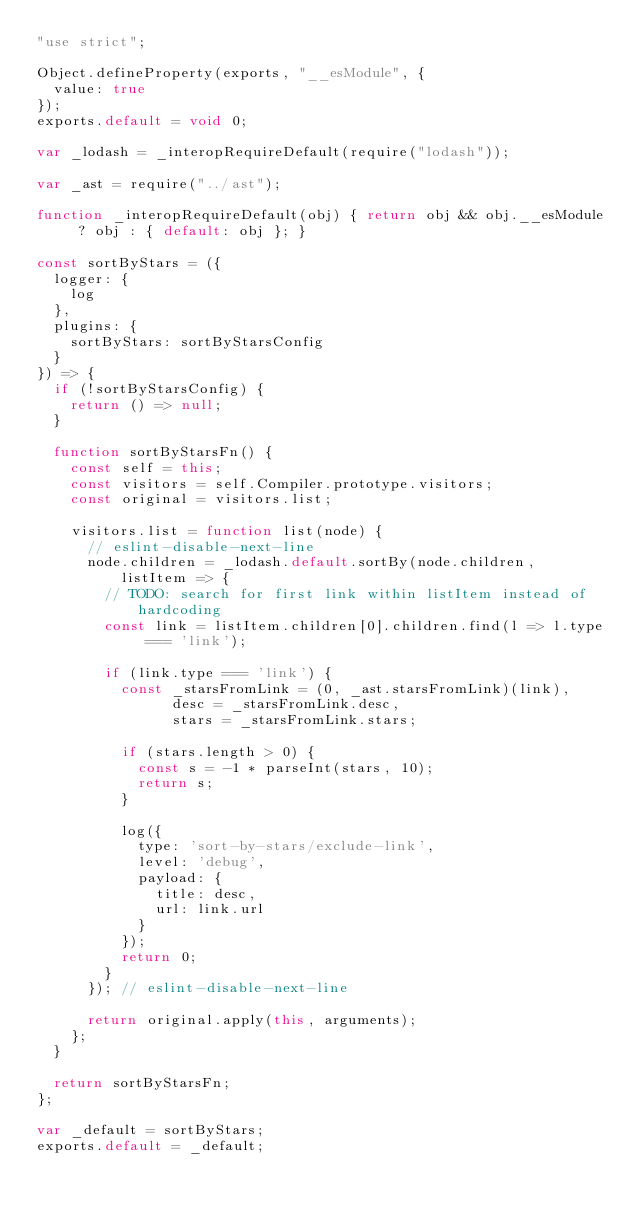Convert code to text. <code><loc_0><loc_0><loc_500><loc_500><_JavaScript_>"use strict";

Object.defineProperty(exports, "__esModule", {
  value: true
});
exports.default = void 0;

var _lodash = _interopRequireDefault(require("lodash"));

var _ast = require("../ast");

function _interopRequireDefault(obj) { return obj && obj.__esModule ? obj : { default: obj }; }

const sortByStars = ({
  logger: {
    log
  },
  plugins: {
    sortByStars: sortByStarsConfig
  }
}) => {
  if (!sortByStarsConfig) {
    return () => null;
  }

  function sortByStarsFn() {
    const self = this;
    const visitors = self.Compiler.prototype.visitors;
    const original = visitors.list;

    visitors.list = function list(node) {
      // eslint-disable-next-line
      node.children = _lodash.default.sortBy(node.children, listItem => {
        // TODO: search for first link within listItem instead of hardcoding
        const link = listItem.children[0].children.find(l => l.type === 'link');

        if (link.type === 'link') {
          const _starsFromLink = (0, _ast.starsFromLink)(link),
                desc = _starsFromLink.desc,
                stars = _starsFromLink.stars;

          if (stars.length > 0) {
            const s = -1 * parseInt(stars, 10);
            return s;
          }

          log({
            type: 'sort-by-stars/exclude-link',
            level: 'debug',
            payload: {
              title: desc,
              url: link.url
            }
          });
          return 0;
        }
      }); // eslint-disable-next-line

      return original.apply(this, arguments);
    };
  }

  return sortByStarsFn;
};

var _default = sortByStars;
exports.default = _default;</code> 